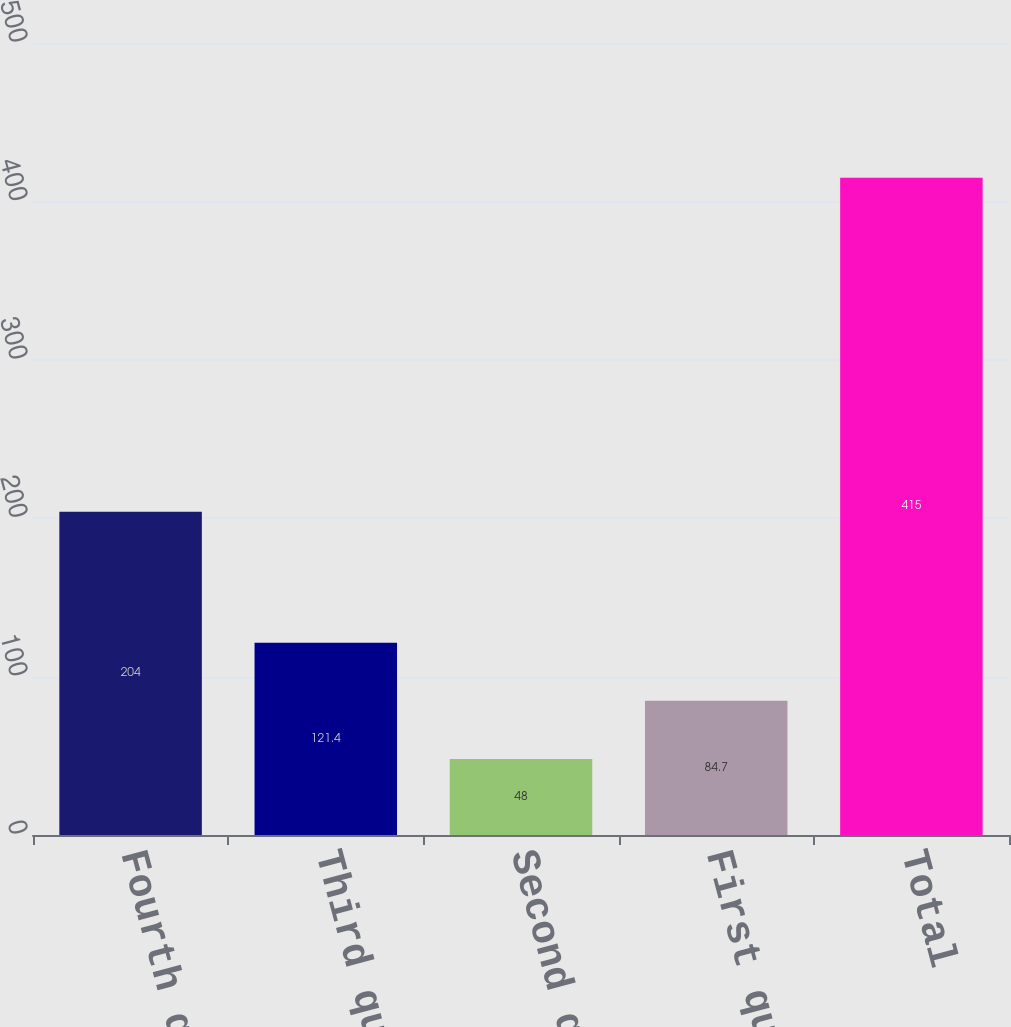Convert chart to OTSL. <chart><loc_0><loc_0><loc_500><loc_500><bar_chart><fcel>Fourth quarter<fcel>Third quarter<fcel>Second quarter<fcel>First quarter<fcel>Total<nl><fcel>204<fcel>121.4<fcel>48<fcel>84.7<fcel>415<nl></chart> 